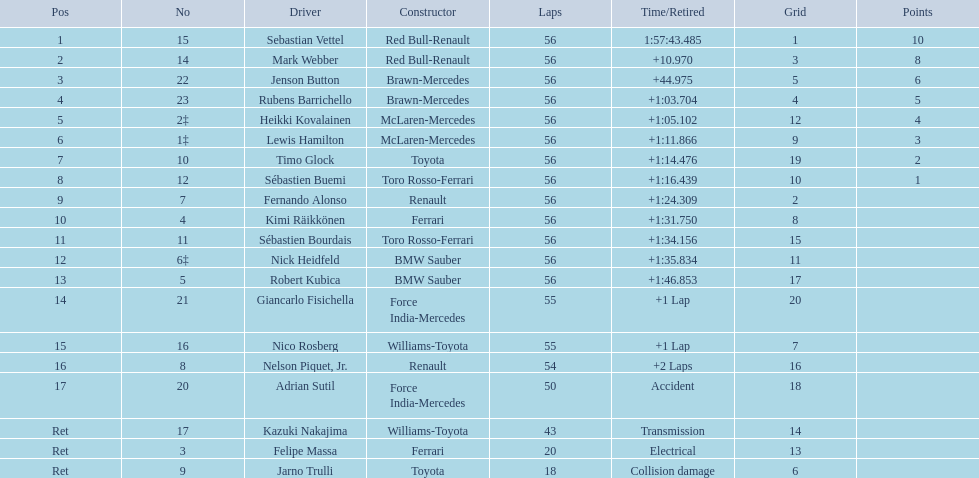Who participated in the 2009 chinese grand prix race? Sebastian Vettel, Mark Webber, Jenson Button, Rubens Barrichello, Heikki Kovalainen, Lewis Hamilton, Timo Glock, Sébastien Buemi, Fernando Alonso, Kimi Räikkönen, Sébastien Bourdais, Nick Heidfeld, Robert Kubica, Giancarlo Fisichella, Nico Rosberg, Nelson Piquet, Jr., Adrian Sutil, Kazuki Nakajima, Felipe Massa, Jarno Trulli. Among the participants, who managed to complete the race? Sebastian Vettel, Mark Webber, Jenson Button, Rubens Barrichello, Heikki Kovalainen, Lewis Hamilton, Timo Glock, Sébastien Buemi, Fernando Alonso, Kimi Räikkönen, Sébastien Bourdais, Nick Heidfeld, Robert Kubica. Out of those who completed the race, who recorded the slowest time? Robert Kubica. 